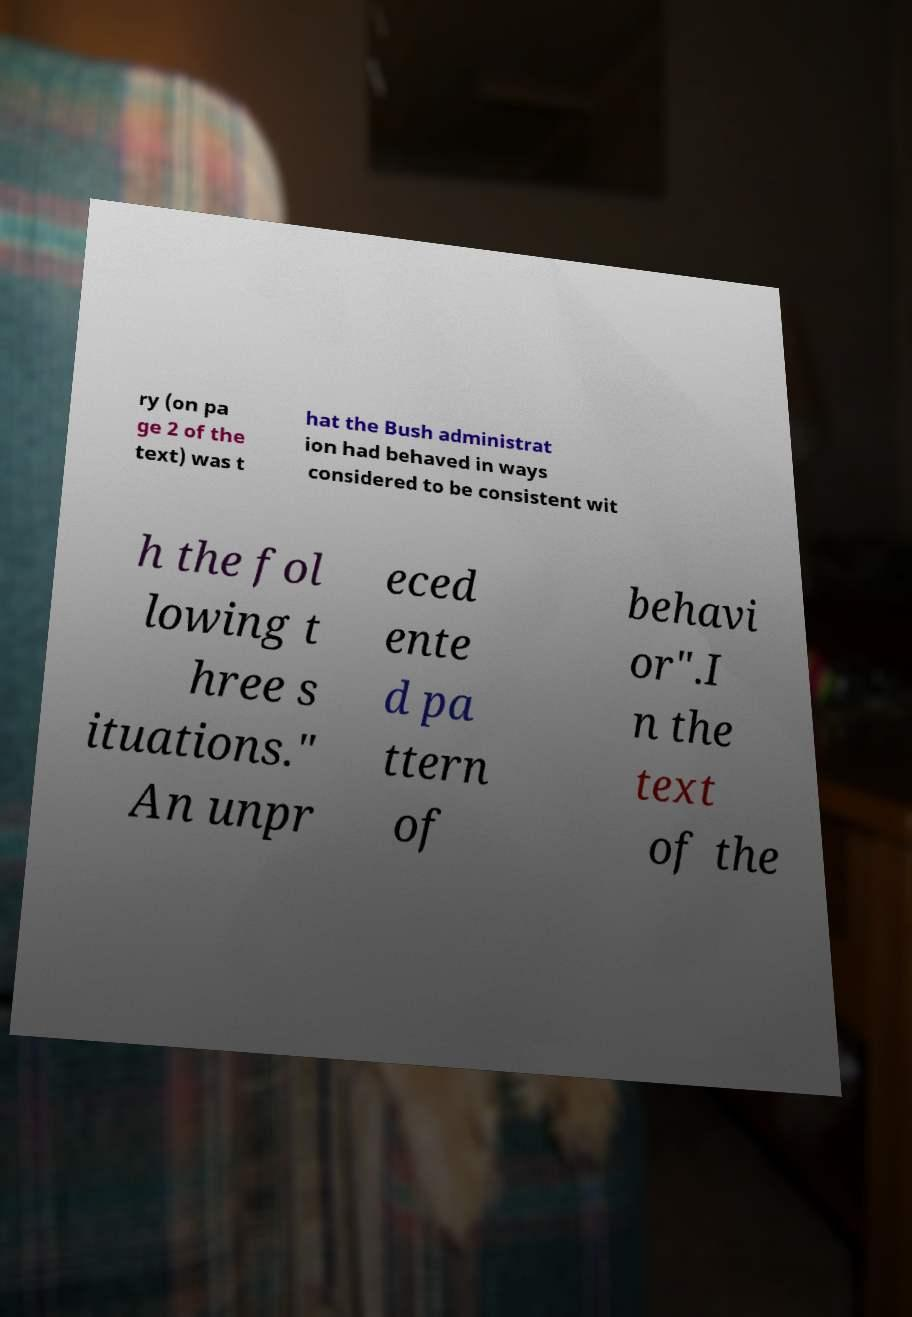For documentation purposes, I need the text within this image transcribed. Could you provide that? ry (on pa ge 2 of the text) was t hat the Bush administrat ion had behaved in ways considered to be consistent wit h the fol lowing t hree s ituations." An unpr eced ente d pa ttern of behavi or".I n the text of the 